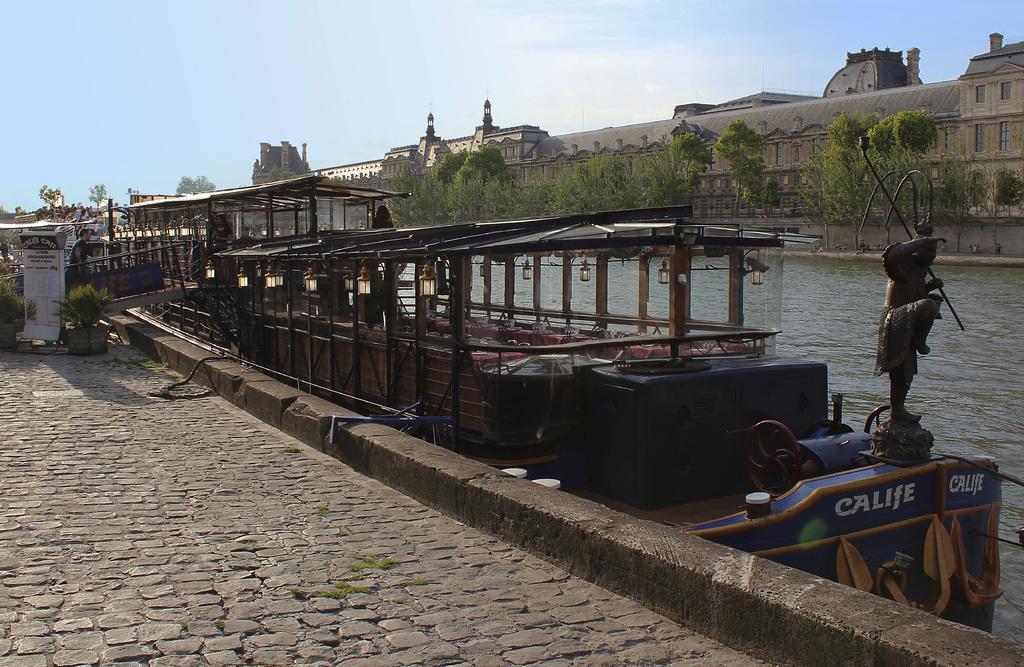Could you give a brief overview of what you see in this image? In this picture I can see the path in front and I see few plants. On the right side of this picture I see the water on which there are boats. In the middle of this picture I see a person and I see number of buildings and trees. In the background I see the clear sky. 